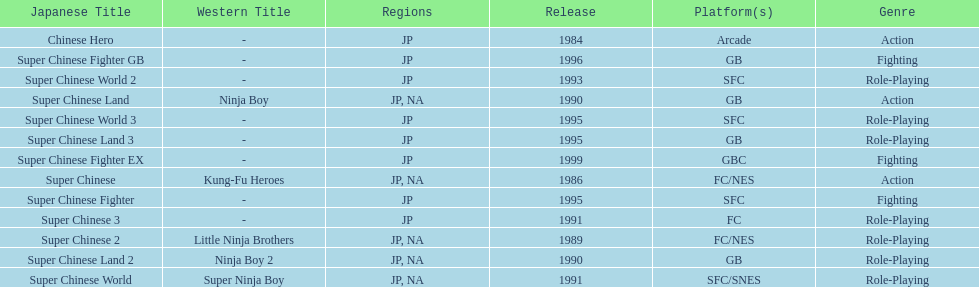Of the titles released in north america, which had the least releases? Super Chinese World. 